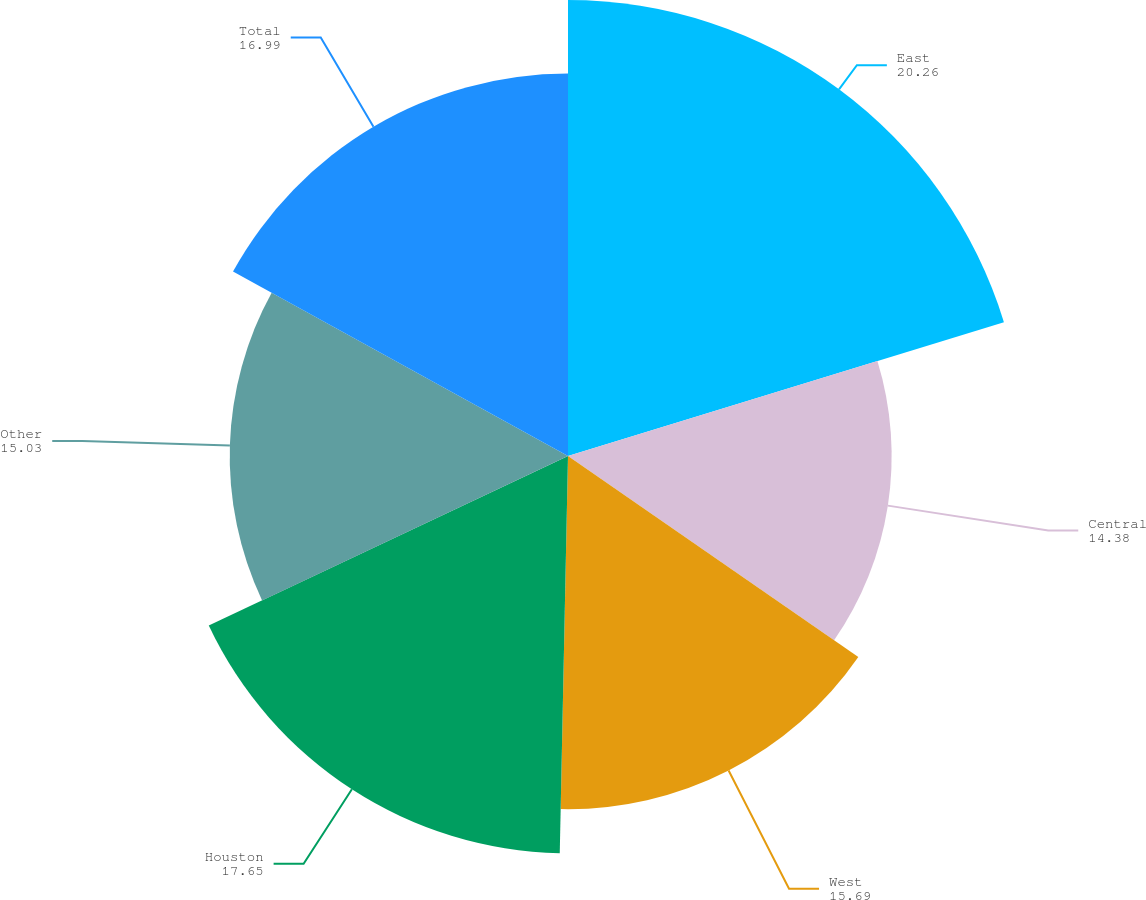Convert chart. <chart><loc_0><loc_0><loc_500><loc_500><pie_chart><fcel>East<fcel>Central<fcel>West<fcel>Houston<fcel>Other<fcel>Total<nl><fcel>20.26%<fcel>14.38%<fcel>15.69%<fcel>17.65%<fcel>15.03%<fcel>16.99%<nl></chart> 